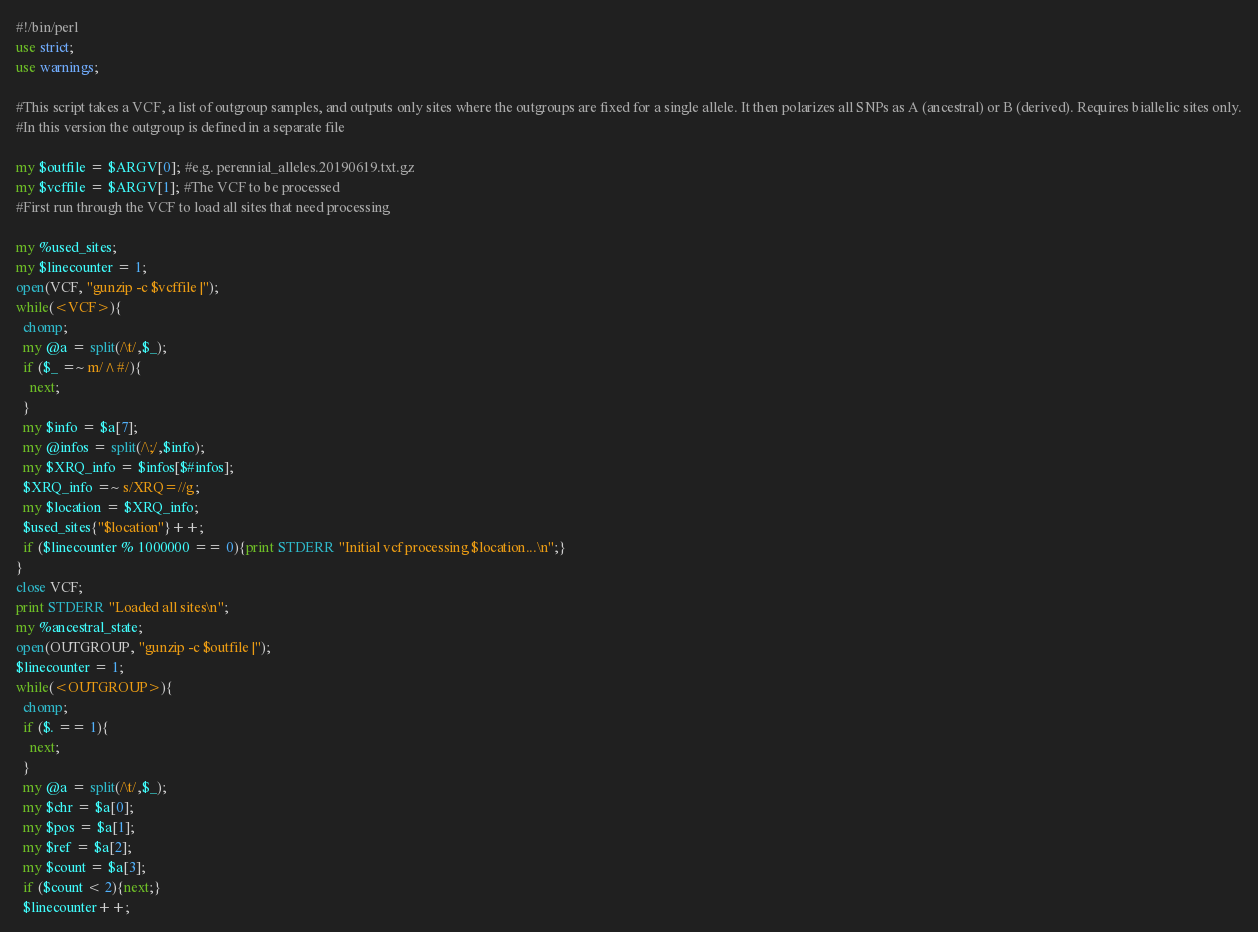Convert code to text. <code><loc_0><loc_0><loc_500><loc_500><_Perl_>#!/bin/perl
use strict;
use warnings;

#This script takes a VCF, a list of outgroup samples, and outputs only sites where the outgroups are fixed for a single allele. It then polarizes all SNPs as A (ancestral) or B (derived). Requires biallelic sites only.
#In this version the outgroup is defined in a separate file

my $outfile = $ARGV[0]; #e.g. perennial_alleles.20190619.txt.gz
my $vcffile = $ARGV[1]; #The VCF to be processed
#First run through the VCF to load all sites that need processing

my %used_sites;
my $linecounter = 1;
open(VCF, "gunzip -c $vcffile |");
while(<VCF>){
  chomp;
  my @a = split(/\t/,$_);
  if ($_ =~ m/^#/){
    next;
  }
  my $info = $a[7];
  my @infos = split(/\;/,$info);
  my $XRQ_info = $infos[$#infos];
  $XRQ_info =~ s/XRQ=//g;
  my $location = $XRQ_info;
  $used_sites{"$location"}++;
  if ($linecounter % 1000000 == 0){print STDERR "Initial vcf processing $location...\n";}
}
close VCF;
print STDERR "Loaded all sites\n";
my %ancestral_state;
open(OUTGROUP, "gunzip -c $outfile |");
$linecounter = 1;
while(<OUTGROUP>){
  chomp;
  if ($. == 1){
    next;
  }
  my @a = split(/\t/,$_);
  my $chr = $a[0];
  my $pos = $a[1];
  my $ref = $a[2];
  my $count = $a[3];
  if ($count < 2){next;}
  $linecounter++;</code> 